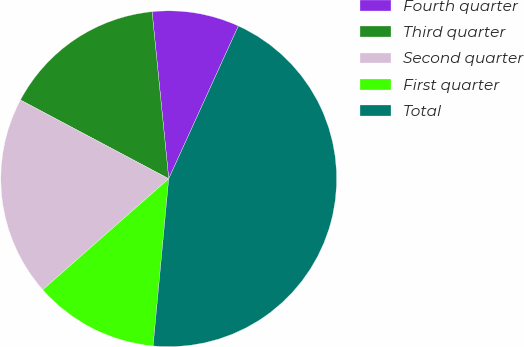<chart> <loc_0><loc_0><loc_500><loc_500><pie_chart><fcel>Fourth quarter<fcel>Third quarter<fcel>Second quarter<fcel>First quarter<fcel>Total<nl><fcel>8.39%<fcel>15.65%<fcel>19.27%<fcel>12.02%<fcel>44.68%<nl></chart> 